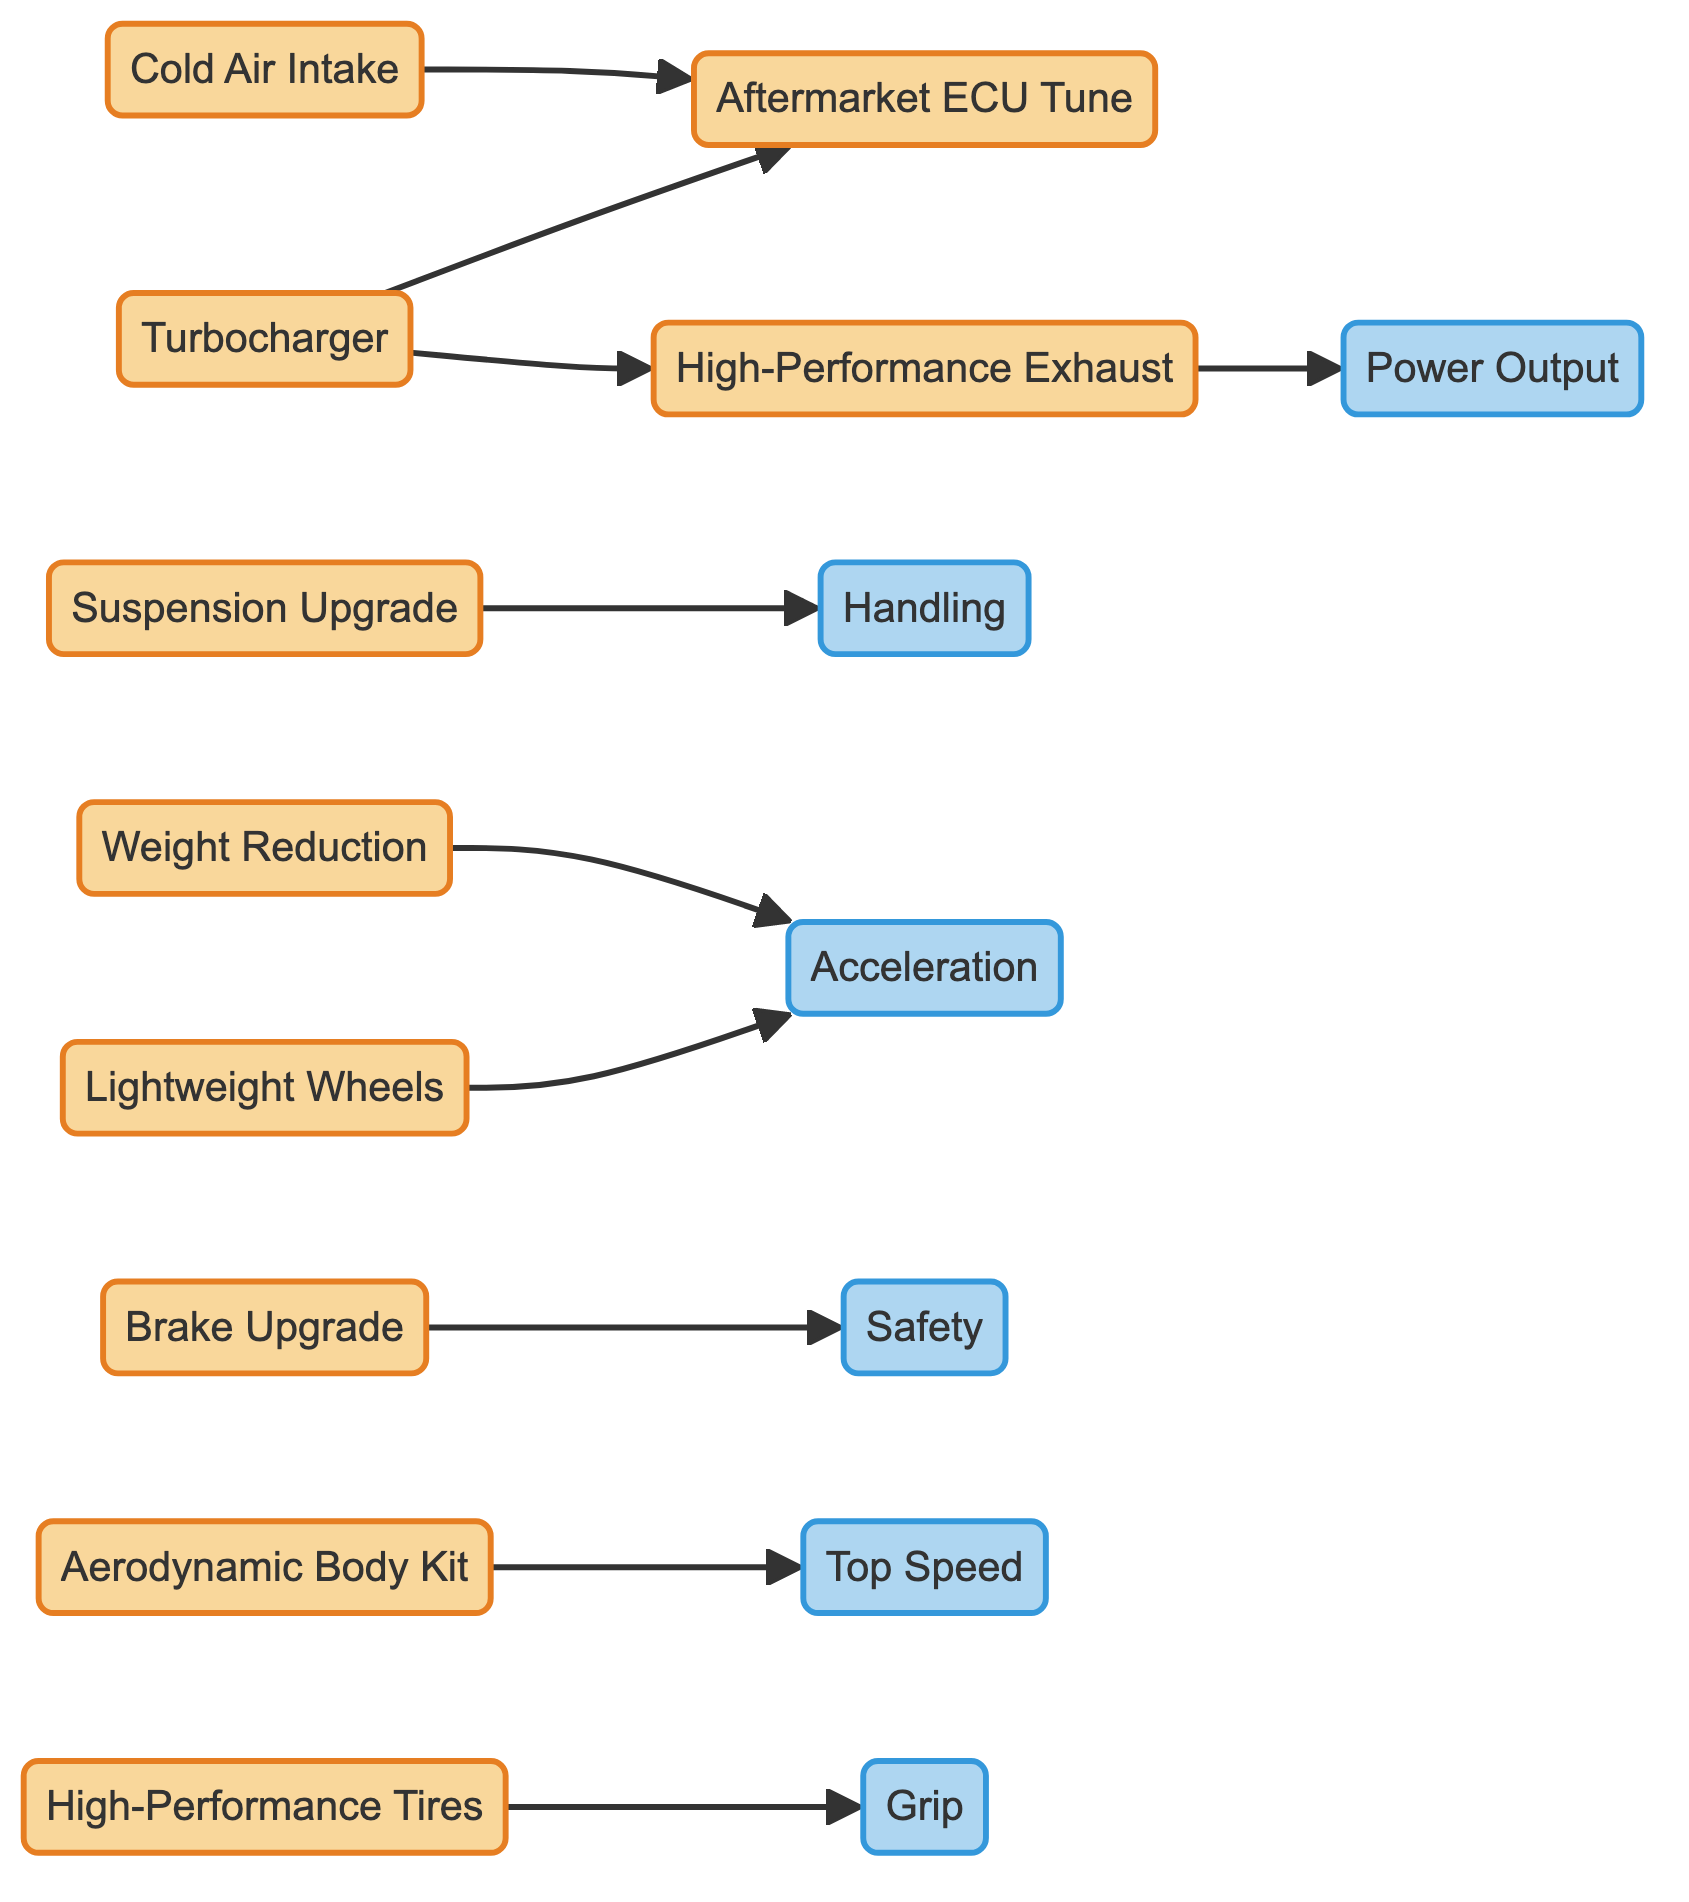What are the modifications that connect to the Aftermarket ECU Tune? In the diagram, the edges show that both the Turbocharger and Cold Air Intake lead to the Aftermarket ECU Tune node. This indicates that both of these modifications influence or require an aftermarket ECU tune.
Answer: Turbocharger, Cold Air Intake How many total nodes are present in the diagram? The diagram contains 10 distinct nodes that represent various car modification techniques and performance aspects. By counting each unique node listed, we confirm there are 10 in total.
Answer: 10 What effect does the High-Performance Exhaust System have? According to the diagram, there is a direct edge from the High-Performance Exhaust to the Power Output node. This implies that upgrading to a High-Performance Exhaust System enhances or directly contributes to the vehicle's power output.
Answer: Power Output Which modification leads to an increase in Grip? The diagram shows that the High-Performance Tires have a direct connection to the Grip node, indicating that upgrading to high-performance tires directly results in improved grip on the vehicle.
Answer: High-Performance Tires Is there any modification that affects both Acceleration and Power Output? Yes, upon examining the diagram, we see two modifications that lead to both Acceleration (Lightweight Wheels and Weight Reduction) and Power Output (High-Performance Exhaust), though these are separate paths. Thus, modifications like Lightweight Wheels and Weight Reduction impact acceleration, while High-Performance Exhaust specifically affects power output.
Answer: Yes Which performance aspect is influenced directly by the Aerodynamic Body Kit? The Aerodynamic Body Kit is directly connected to the Top Speed node in the diagram. This indicates that the addition of an aerodynamic kit will increase or have a direct effect on the vehicle's top speed.
Answer: Top Speed How many edges are there in total connecting the modifications to performance aspects? To find the total edges, we simply count the connections (from one node to another) displayed in the diagram. There are 10 edges shown that represent direct relationships between modifications and performance aspects.
Answer: 10 What is the indirect effect of Weight Reduction on vehicle performance? Weight Reduction connects to the Acceleration node, which means that when the weight of the vehicle is reduced, it indirectly improves the acceleration performance. This showcases the relationship between reducing weight and enhancing acceleration capabilities.
Answer: Acceleration 